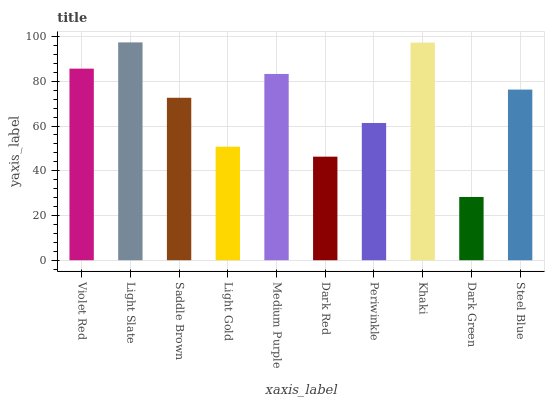Is Dark Green the minimum?
Answer yes or no. Yes. Is Light Slate the maximum?
Answer yes or no. Yes. Is Saddle Brown the minimum?
Answer yes or no. No. Is Saddle Brown the maximum?
Answer yes or no. No. Is Light Slate greater than Saddle Brown?
Answer yes or no. Yes. Is Saddle Brown less than Light Slate?
Answer yes or no. Yes. Is Saddle Brown greater than Light Slate?
Answer yes or no. No. Is Light Slate less than Saddle Brown?
Answer yes or no. No. Is Steel Blue the high median?
Answer yes or no. Yes. Is Saddle Brown the low median?
Answer yes or no. Yes. Is Light Gold the high median?
Answer yes or no. No. Is Dark Red the low median?
Answer yes or no. No. 